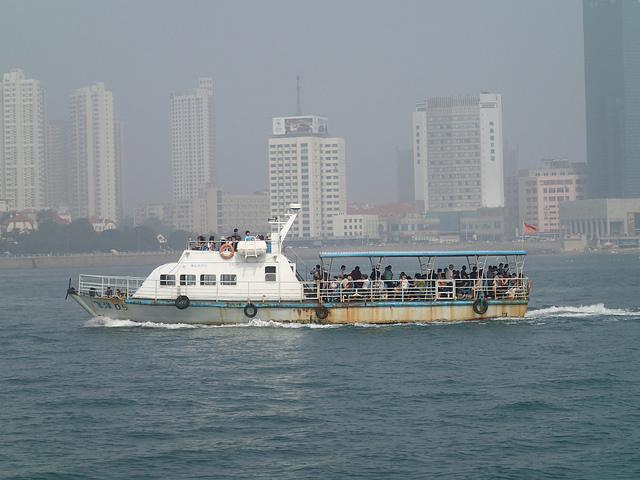Where are the people on the boat ultimately headed? shore 